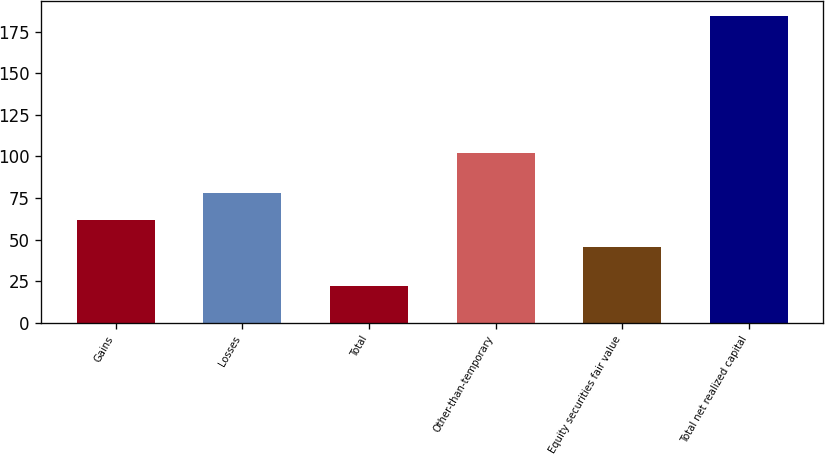Convert chart to OTSL. <chart><loc_0><loc_0><loc_500><loc_500><bar_chart><fcel>Gains<fcel>Losses<fcel>Total<fcel>Other-than-temporary<fcel>Equity securities fair value<fcel>Total net realized capital<nl><fcel>61.78<fcel>77.96<fcel>22.3<fcel>102.2<fcel>45.6<fcel>184.1<nl></chart> 